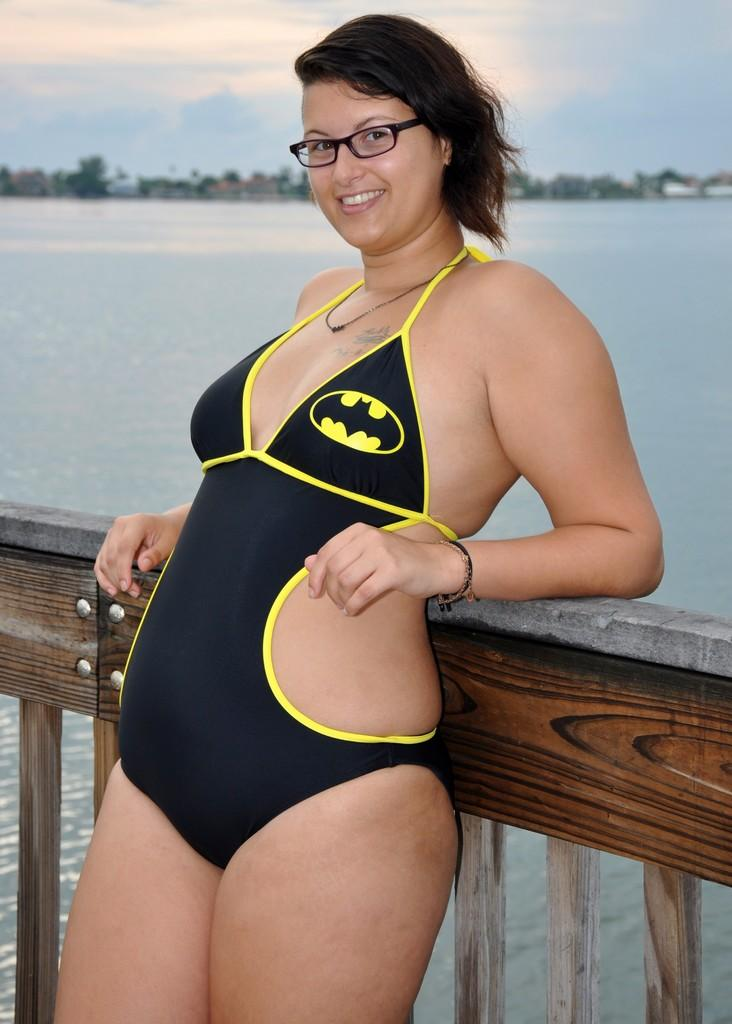What is the woman doing in the image? The woman is standing in the image and leaning on a wooden fence. How does the woman appear to be feeling in the image? The woman has a smile on her face, which suggests she is happy or content. What can be seen behind the woman in the image? There is water visible behind the woman. What type of vegetation is present in the background of the image? There are trees in the background of the image. What type of books can be seen in the library in the image? There is no library present in the image; it features a woman standing near a wooden fence with water and trees in the background. 